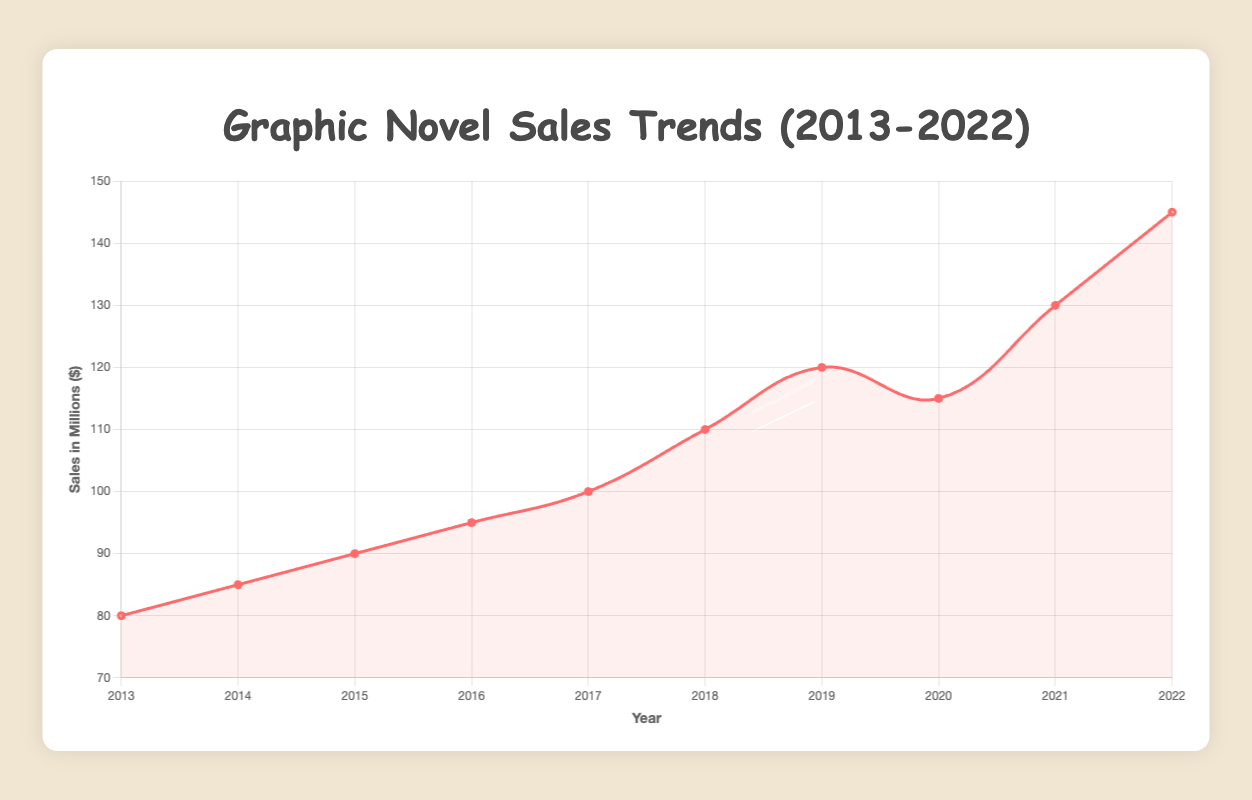What's the trend of total sales from 2013 to 2022? Observing the line chart, the total sales show an upward trend from 80 million in 2013 to 145 million in 2022, with a slight dip in 2020.
Answer: Upward What was the total sales value in 2017, and how does it compare to 2020? The total sales in 2017 were 100 million, and in 2020 it was 115 million. This shows an increase of 15 million from 2017 to 2020.
Answer: 100 million; increase by 15 million What is the average sales value over the decade? Sum the total sales values (80 + 85 + 90 + 95 + 100 + 110 + 120 + 115 + 130 + 145 = 1070) and divide by the number of years (10). The average sales value is 1070 / 10 = 107 million.
Answer: 107 million Compare the total sales in 2019 to the total sales in 2021. Which one is higher? The total sales in 2019 were 120 million, and in 2021 it was 130 million. Therefore, 2021 has higher total sales.
Answer: 2021 Identify the year with the highest sales and list the major releases for that year. The highest sales were in 2022, at 145 million. The major releases for 2022 were "Crisis Zone" and "Sheets."
Answer: 2022; "Crisis Zone" and "Sheets" Which year saw the largest year-over-year increase in sales? By comparing the year-over-year increases: (2014-2013)=5 million, (2015-2014)=5 million, (2016-2015)=5 million, (2017-2016)=5 million, (2018-2017)=10 million, (2019-2018)=10 million, (2020-2019)=-5 million, (2021-2020)=15 million, (2022-2021)=15 million, the largest increases are in 2021 and 2022, both by 15 million.
Answer: 2021 and 2022 How did the total sales change from the first year to the last year? The total sales in 2013 were 80 million, and in 2022 it was 145 million. The change is 145 - 80 = 65 million.
Answer: Increase by 65 million Which year experienced a sales dip, and what could be the reason? The sales dipped in 2020, from 120 million in 2019 to 115 million. The annotation notes the pandemic impact as a reason for this dip.
Answer: 2020; pandemic impact What general observation can be made about the sales trajectory from 2013 to 2022? The sales trajectory generally shows significant growth with a slight dip in 2020 due to the pandemic, followed by strong recovery in subsequent years.
Answer: Significant growth with a dip in 2020 and recovery afterwards 